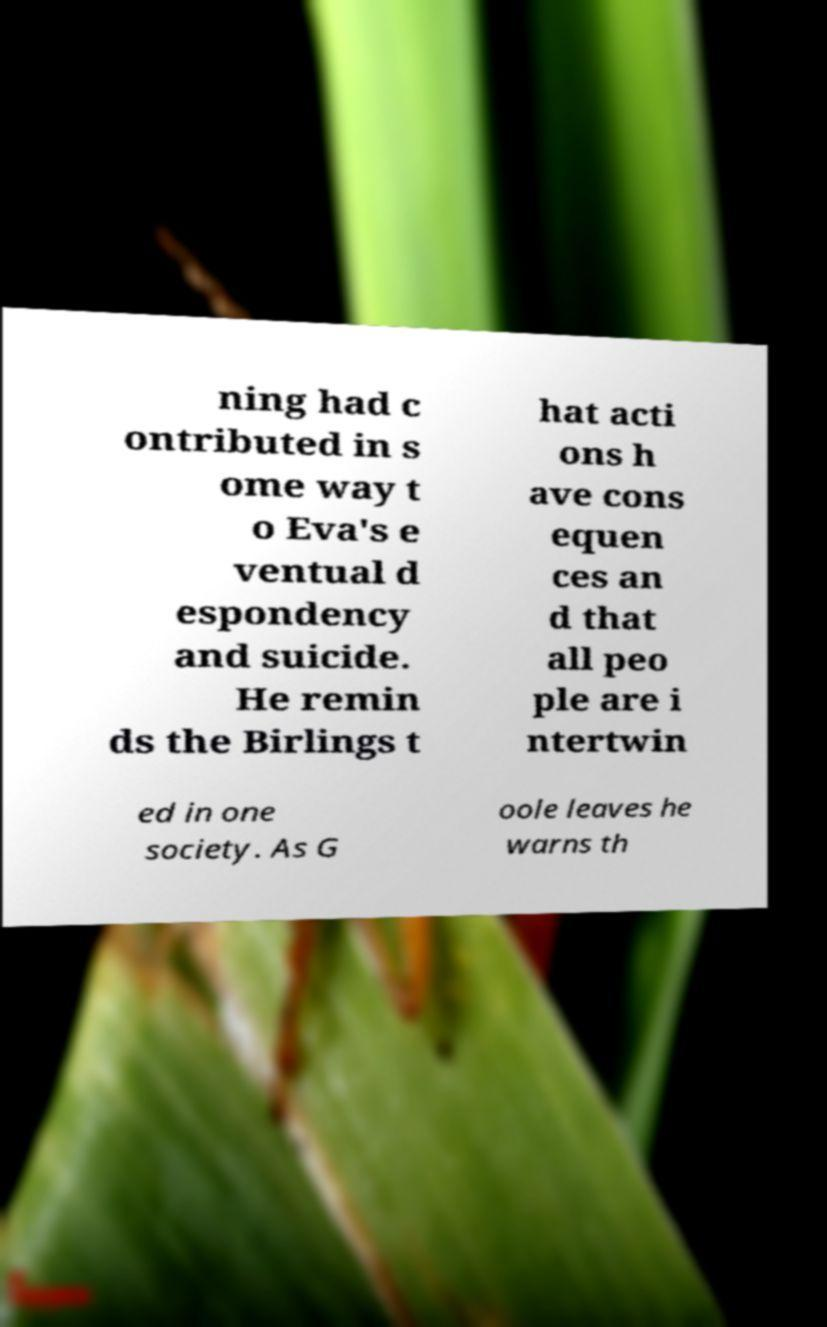What messages or text are displayed in this image? I need them in a readable, typed format. ning had c ontributed in s ome way t o Eva's e ventual d espondency and suicide. He remin ds the Birlings t hat acti ons h ave cons equen ces an d that all peo ple are i ntertwin ed in one society. As G oole leaves he warns th 